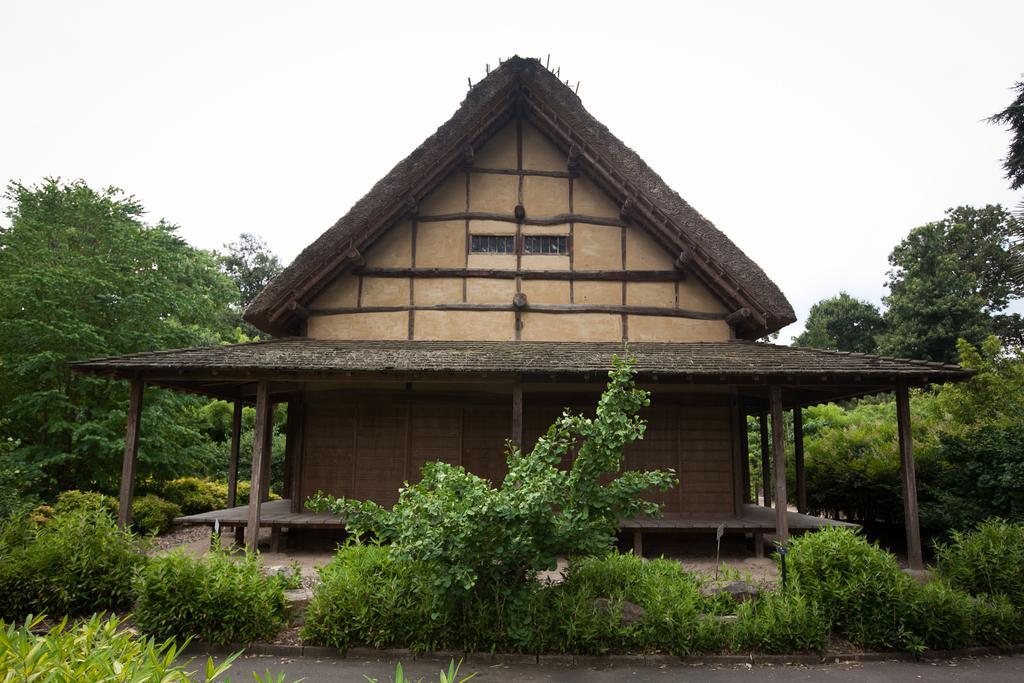Can you describe this image briefly? In this image we can see water and plants at the bottom. In the background we can see a house, trees and the sky. 